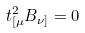<formula> <loc_0><loc_0><loc_500><loc_500>t ^ { 2 } _ { [ \mu } B _ { \nu ] } = 0</formula> 